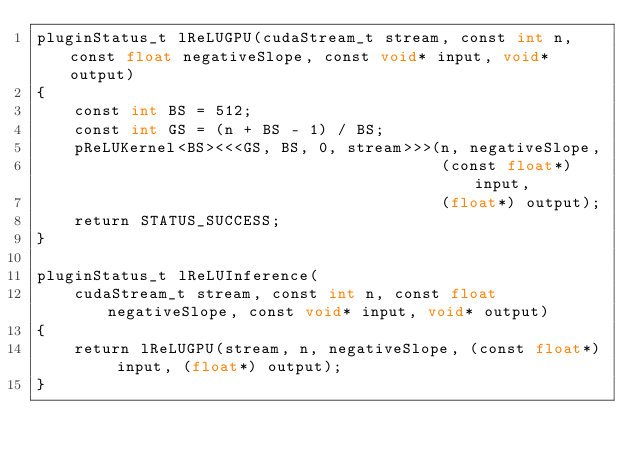<code> <loc_0><loc_0><loc_500><loc_500><_Cuda_>pluginStatus_t lReLUGPU(cudaStream_t stream, const int n, const float negativeSlope, const void* input, void* output)
{
    const int BS = 512;
    const int GS = (n + BS - 1) / BS;
    pReLUKernel<BS><<<GS, BS, 0, stream>>>(n, negativeSlope,
                                           (const float*) input,
                                           (float*) output);
    return STATUS_SUCCESS;
}

pluginStatus_t lReLUInference(
    cudaStream_t stream, const int n, const float negativeSlope, const void* input, void* output)
{
    return lReLUGPU(stream, n, negativeSlope, (const float*) input, (float*) output);
}
</code> 